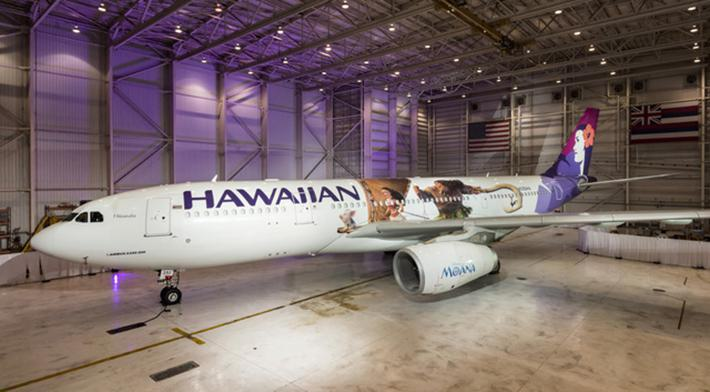Can you discuss the significance of the setting in which the airplane is located? The airplane is housed in a large hangar, suggesting this setting is likely used for maintenance or pre-flight preparations. Hangars are critical for ensuring that aircraft are kept in optimal condition and safe for future flights, highlighting the importance of such facilities in aviation operations. 